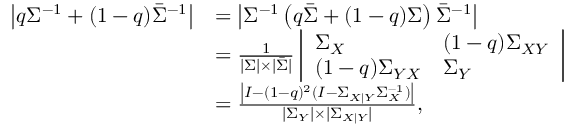<formula> <loc_0><loc_0><loc_500><loc_500>\begin{array} { r l } { \left | q \Sigma ^ { - 1 } + ( 1 - q ) \bar { \Sigma } ^ { - 1 } \right | } & { = \left | \Sigma ^ { - 1 } \left ( q \bar { \Sigma } + ( 1 - q ) \Sigma \right ) \bar { \Sigma } ^ { - 1 } \right | } \\ & { = \frac { 1 } { | \Sigma | \times | \bar { \Sigma } | } \left | \begin{array} { l l } { \Sigma _ { X } } & { ( 1 - q ) \Sigma _ { X Y } } \\ { ( 1 - q ) \Sigma _ { Y X } } & { \Sigma _ { Y } } \end{array} \right | } \\ & { = \frac { \left | I - ( 1 - q ) ^ { 2 } ( I - \Sigma _ { X | Y } \Sigma _ { X } ^ { - 1 } ) \right | } { | \Sigma _ { Y } | \times | \Sigma _ { X | Y } | } , } \end{array}</formula> 